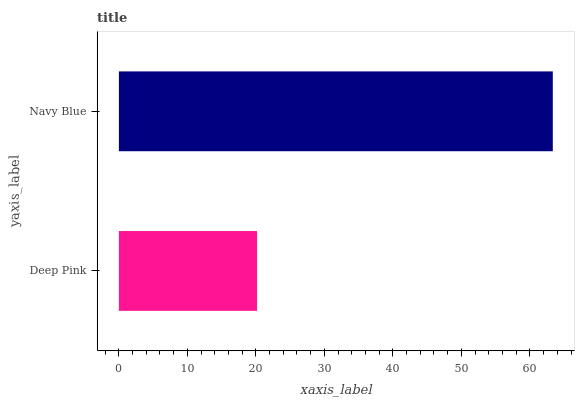Is Deep Pink the minimum?
Answer yes or no. Yes. Is Navy Blue the maximum?
Answer yes or no. Yes. Is Navy Blue the minimum?
Answer yes or no. No. Is Navy Blue greater than Deep Pink?
Answer yes or no. Yes. Is Deep Pink less than Navy Blue?
Answer yes or no. Yes. Is Deep Pink greater than Navy Blue?
Answer yes or no. No. Is Navy Blue less than Deep Pink?
Answer yes or no. No. Is Navy Blue the high median?
Answer yes or no. Yes. Is Deep Pink the low median?
Answer yes or no. Yes. Is Deep Pink the high median?
Answer yes or no. No. Is Navy Blue the low median?
Answer yes or no. No. 